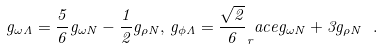Convert formula to latex. <formula><loc_0><loc_0><loc_500><loc_500>g _ { \omega \Lambda } = \frac { 5 } { 6 } g _ { \omega N } - \frac { 1 } { 2 } g _ { \rho N } , \, g _ { \phi \Lambda } = \frac { \sqrt { 2 } } { 6 } _ { r } a c e { g _ { \omega N } + 3 g _ { \rho N } } \ .</formula> 